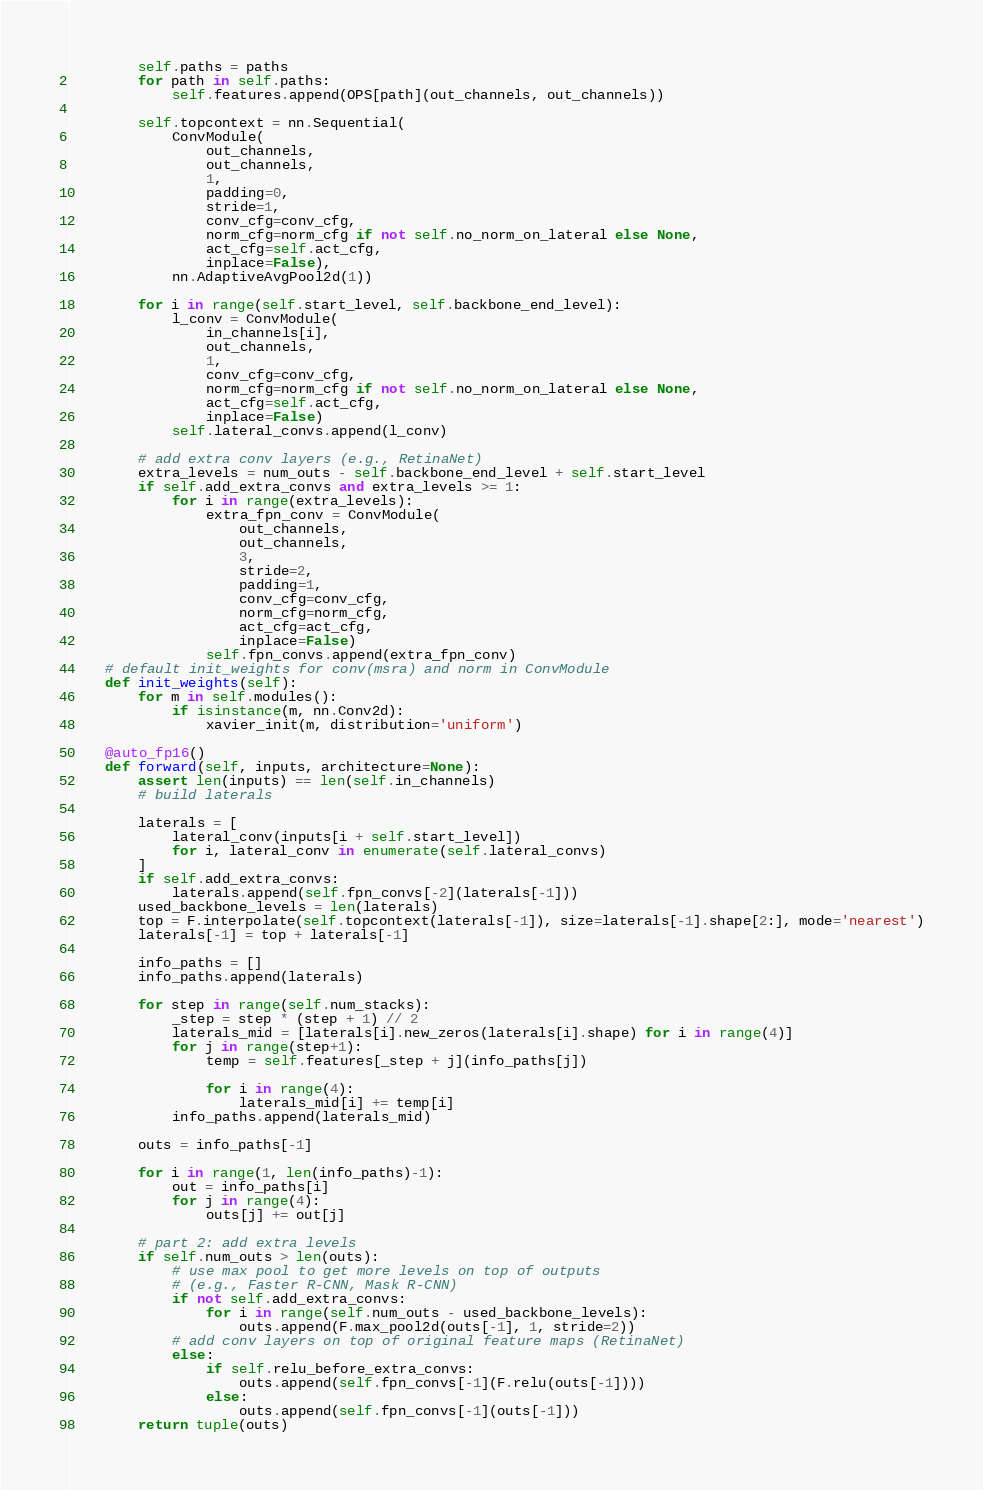<code> <loc_0><loc_0><loc_500><loc_500><_Python_>		self.paths = paths
		for path in self.paths:
			self.features.append(OPS[path](out_channels, out_channels))

		self.topcontext = nn.Sequential(
			ConvModule(
				out_channels,
				out_channels,
				1,
				padding=0,
				stride=1,
				conv_cfg=conv_cfg,
				norm_cfg=norm_cfg if not self.no_norm_on_lateral else None,
				act_cfg=self.act_cfg,
				inplace=False),
			nn.AdaptiveAvgPool2d(1))

		for i in range(self.start_level, self.backbone_end_level):
			l_conv = ConvModule(
				in_channels[i],
				out_channels,
				1,
				conv_cfg=conv_cfg,
				norm_cfg=norm_cfg if not self.no_norm_on_lateral else None,
				act_cfg=self.act_cfg,
				inplace=False)
			self.lateral_convs.append(l_conv)

		# add extra conv layers (e.g., RetinaNet)
		extra_levels = num_outs - self.backbone_end_level + self.start_level
		if self.add_extra_convs and extra_levels >= 1:
			for i in range(extra_levels):
				extra_fpn_conv = ConvModule(
					out_channels,
					out_channels,
					3,
					stride=2,
					padding=1,
					conv_cfg=conv_cfg,
					norm_cfg=norm_cfg,
					act_cfg=act_cfg,
					inplace=False)
				self.fpn_convs.append(extra_fpn_conv)
	# default init_weights for conv(msra) and norm in ConvModule
	def init_weights(self):
		for m in self.modules():
			if isinstance(m, nn.Conv2d):
				xavier_init(m, distribution='uniform')

	@auto_fp16()
	def forward(self, inputs, architecture=None):
		assert len(inputs) == len(self.in_channels)
		# build laterals

		laterals = [
			lateral_conv(inputs[i + self.start_level])
			for i, lateral_conv in enumerate(self.lateral_convs)
		]
		if self.add_extra_convs:
			laterals.append(self.fpn_convs[-2](laterals[-1]))
		used_backbone_levels = len(laterals)
		top = F.interpolate(self.topcontext(laterals[-1]), size=laterals[-1].shape[2:], mode='nearest')
		laterals[-1] = top + laterals[-1]

		info_paths = []
		info_paths.append(laterals)

		for step in range(self.num_stacks):
			_step = step * (step + 1) // 2
			laterals_mid = [laterals[i].new_zeros(laterals[i].shape) for i in range(4)]
			for j in range(step+1):
				temp = self.features[_step + j](info_paths[j])

				for i in range(4):
					laterals_mid[i] += temp[i]
			info_paths.append(laterals_mid)

		outs = info_paths[-1]

		for i in range(1, len(info_paths)-1):
			out = info_paths[i]
			for j in range(4):
				outs[j] += out[j]

		# part 2: add extra levels
		if self.num_outs > len(outs):
			# use max pool to get more levels on top of outputs
			# (e.g., Faster R-CNN, Mask R-CNN)
			if not self.add_extra_convs:
				for i in range(self.num_outs - used_backbone_levels):
					outs.append(F.max_pool2d(outs[-1], 1, stride=2))
			# add conv layers on top of original feature maps (RetinaNet)
			else:
				if self.relu_before_extra_convs:
					outs.append(self.fpn_convs[-1](F.relu(outs[-1])))
				else:
					outs.append(self.fpn_convs[-1](outs[-1]))
		return tuple(outs)
</code> 